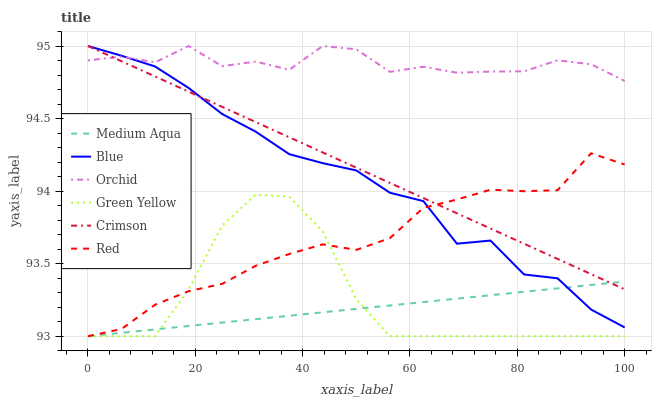Does Medium Aqua have the minimum area under the curve?
Answer yes or no. Yes. Does Orchid have the maximum area under the curve?
Answer yes or no. Yes. Does Crimson have the minimum area under the curve?
Answer yes or no. No. Does Crimson have the maximum area under the curve?
Answer yes or no. No. Is Medium Aqua the smoothest?
Answer yes or no. Yes. Is Orchid the roughest?
Answer yes or no. Yes. Is Crimson the smoothest?
Answer yes or no. No. Is Crimson the roughest?
Answer yes or no. No. Does Crimson have the lowest value?
Answer yes or no. No. Does Orchid have the highest value?
Answer yes or no. Yes. Does Medium Aqua have the highest value?
Answer yes or no. No. Is Red less than Orchid?
Answer yes or no. Yes. Is Orchid greater than Medium Aqua?
Answer yes or no. Yes. Does Red intersect Green Yellow?
Answer yes or no. Yes. Is Red less than Green Yellow?
Answer yes or no. No. Is Red greater than Green Yellow?
Answer yes or no. No. Does Red intersect Orchid?
Answer yes or no. No. 